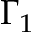<formula> <loc_0><loc_0><loc_500><loc_500>\Gamma _ { 1 }</formula> 